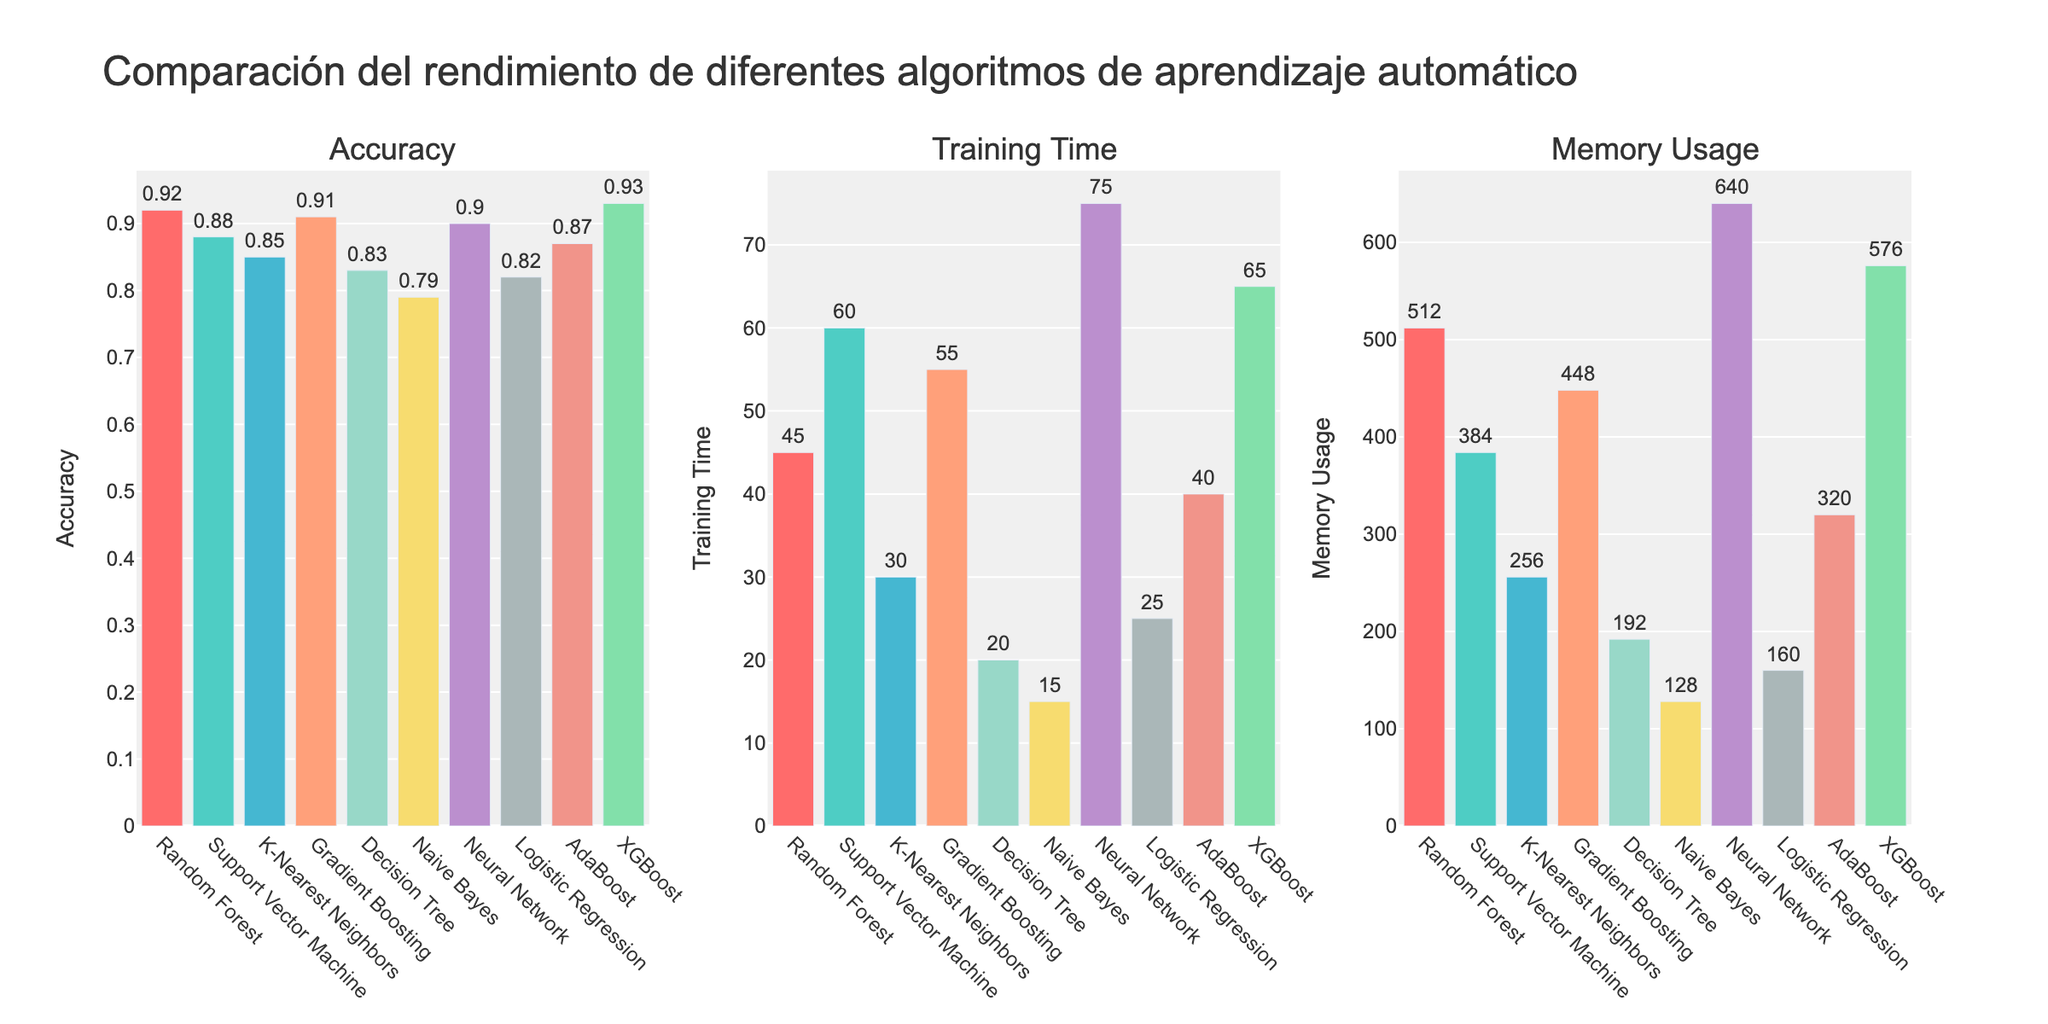What's the algorithm with the highest accuracy? The "Accuracy" bar chart indicates that XGBoost has the highest bar, meaning it has the highest accuracy among the algorithms listed.
Answer: XGBoost Which algorithm has the lowest memory usage? From the "Memory Usage" bar chart, the bar for Naive Bayes is the smallest, indicating that it has the lowest memory usage.
Answer: Naive Bayes How much longer does XGBoost take to train compared to Naive Bayes? The "Training Time" bar for XGBoost is at 65 seconds, while Naive Bayes is at 15 seconds. Therefore, the training time difference is 65 - 15 = 50 seconds.
Answer: 50 seconds Which algorithm achieved an accuracy higher than 0.90 but less than 0.92? By examining the "Accuracy" chart, Random Forest, Gradient Boosting, and Neural Network all have accuracies close to 0.92. Neural Network is at 0.90, so Gradient Boosting with 0.91 fits the criteria.
Answer: Gradient Boosting If you average the Memory Usage of Neural Network and Random Forest, what is the resulting value? From the "Memory Usage" bar chart, Neural Network uses 640 MB, and Random Forest uses 512 MB. The average is (640 + 512) / 2 = 576 MB.
Answer: 576 MB Which algorithm balances both relatively low memory usage and decent accuracy? From the "Memory Usage" and "Accuracy" charts, K-Nearest Neighbors uses 256 MB of memory and has an accuracy of 85%. Both are fairly balanced compared to other algorithms.
Answer: K-Nearest Neighbors Which algorithm takes the least time to train? The "Training Time" bar chart shows that Naive Bayes has the lowest training time at 15 seconds.
Answer: Naive Bayes Compare the Summary of Gradient Boosting and Neural Network. Gradient Boosting has an accuracy of 0.91, takes 55 seconds to train, and uses 448 MB of memory. Neural Network has an accuracy of 0.90, takes 75 seconds to train, and uses 640 MB of memory. Gradient Boosting has slightly better accuracy, faster training time, and less memory usage compared to Neural Network.
Answer: Gradient Boosting is better in accuracy, training time, and memory usage How does the training time of Support Vector Machine compare to the training time of the Decision Tree? The "Training Time" bar chart shows that the Support Vector Machine takes 60 seconds to train, while the Decision Tree takes 20 seconds. Support Vector Machine takes 40 seconds longer to train.
Answer: Support Vector Machine takes 40 seconds longer 